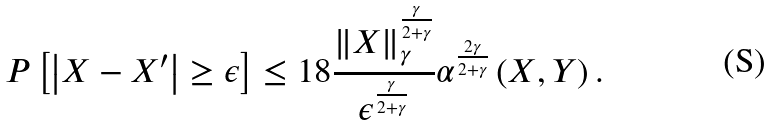Convert formula to latex. <formula><loc_0><loc_0><loc_500><loc_500>P \left [ \left | X - X ^ { \prime } \right | \geq \epsilon \right ] \leq 1 8 \frac { \left \| X \right \| _ { \gamma } ^ { \frac { \gamma } { 2 + \gamma } } } { \epsilon ^ { \frac { \gamma } { 2 + \gamma } } } \alpha ^ { \frac { 2 \gamma } { 2 + \gamma } } \left ( X , Y \right ) .</formula> 